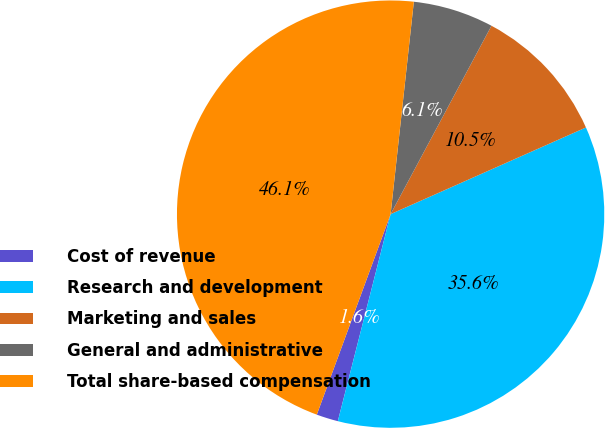Convert chart to OTSL. <chart><loc_0><loc_0><loc_500><loc_500><pie_chart><fcel>Cost of revenue<fcel>Research and development<fcel>Marketing and sales<fcel>General and administrative<fcel>Total share-based compensation<nl><fcel>1.64%<fcel>35.62%<fcel>10.53%<fcel>6.09%<fcel>46.12%<nl></chart> 